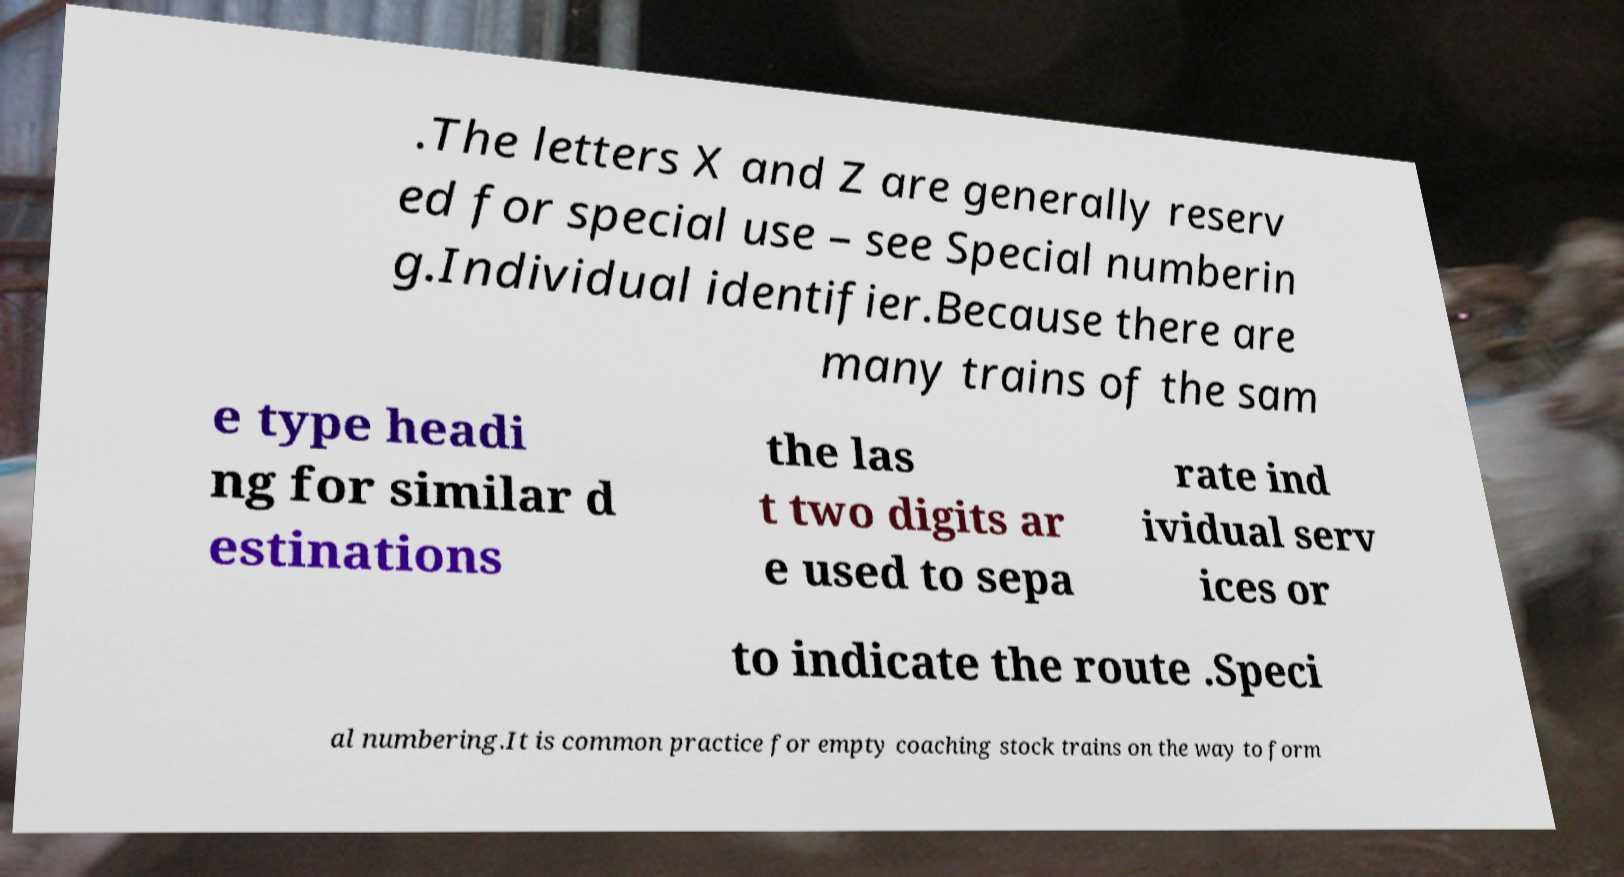I need the written content from this picture converted into text. Can you do that? .The letters X and Z are generally reserv ed for special use – see Special numberin g.Individual identifier.Because there are many trains of the sam e type headi ng for similar d estinations the las t two digits ar e used to sepa rate ind ividual serv ices or to indicate the route .Speci al numbering.It is common practice for empty coaching stock trains on the way to form 